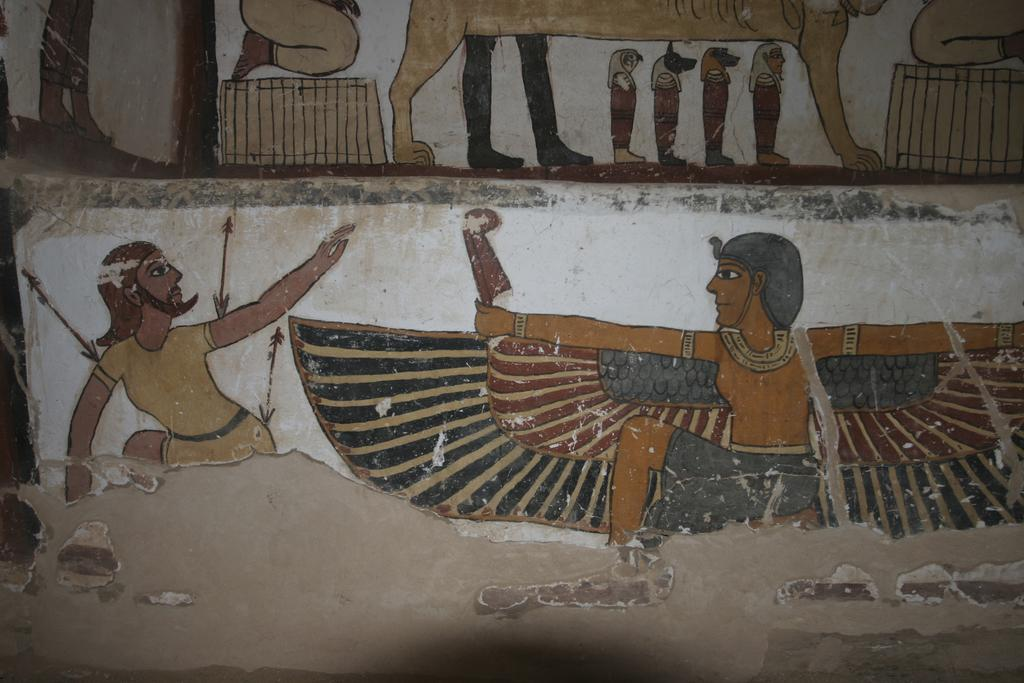What is depicted on the wall in the image? There are paintings on the wall in the image. How many cherries are on the table in the image? There is no table or cherries present in the image; it only features paintings on the wall. What type of learning material can be seen in the image? There is no learning material present in the image; it only features paintings on the wall. 